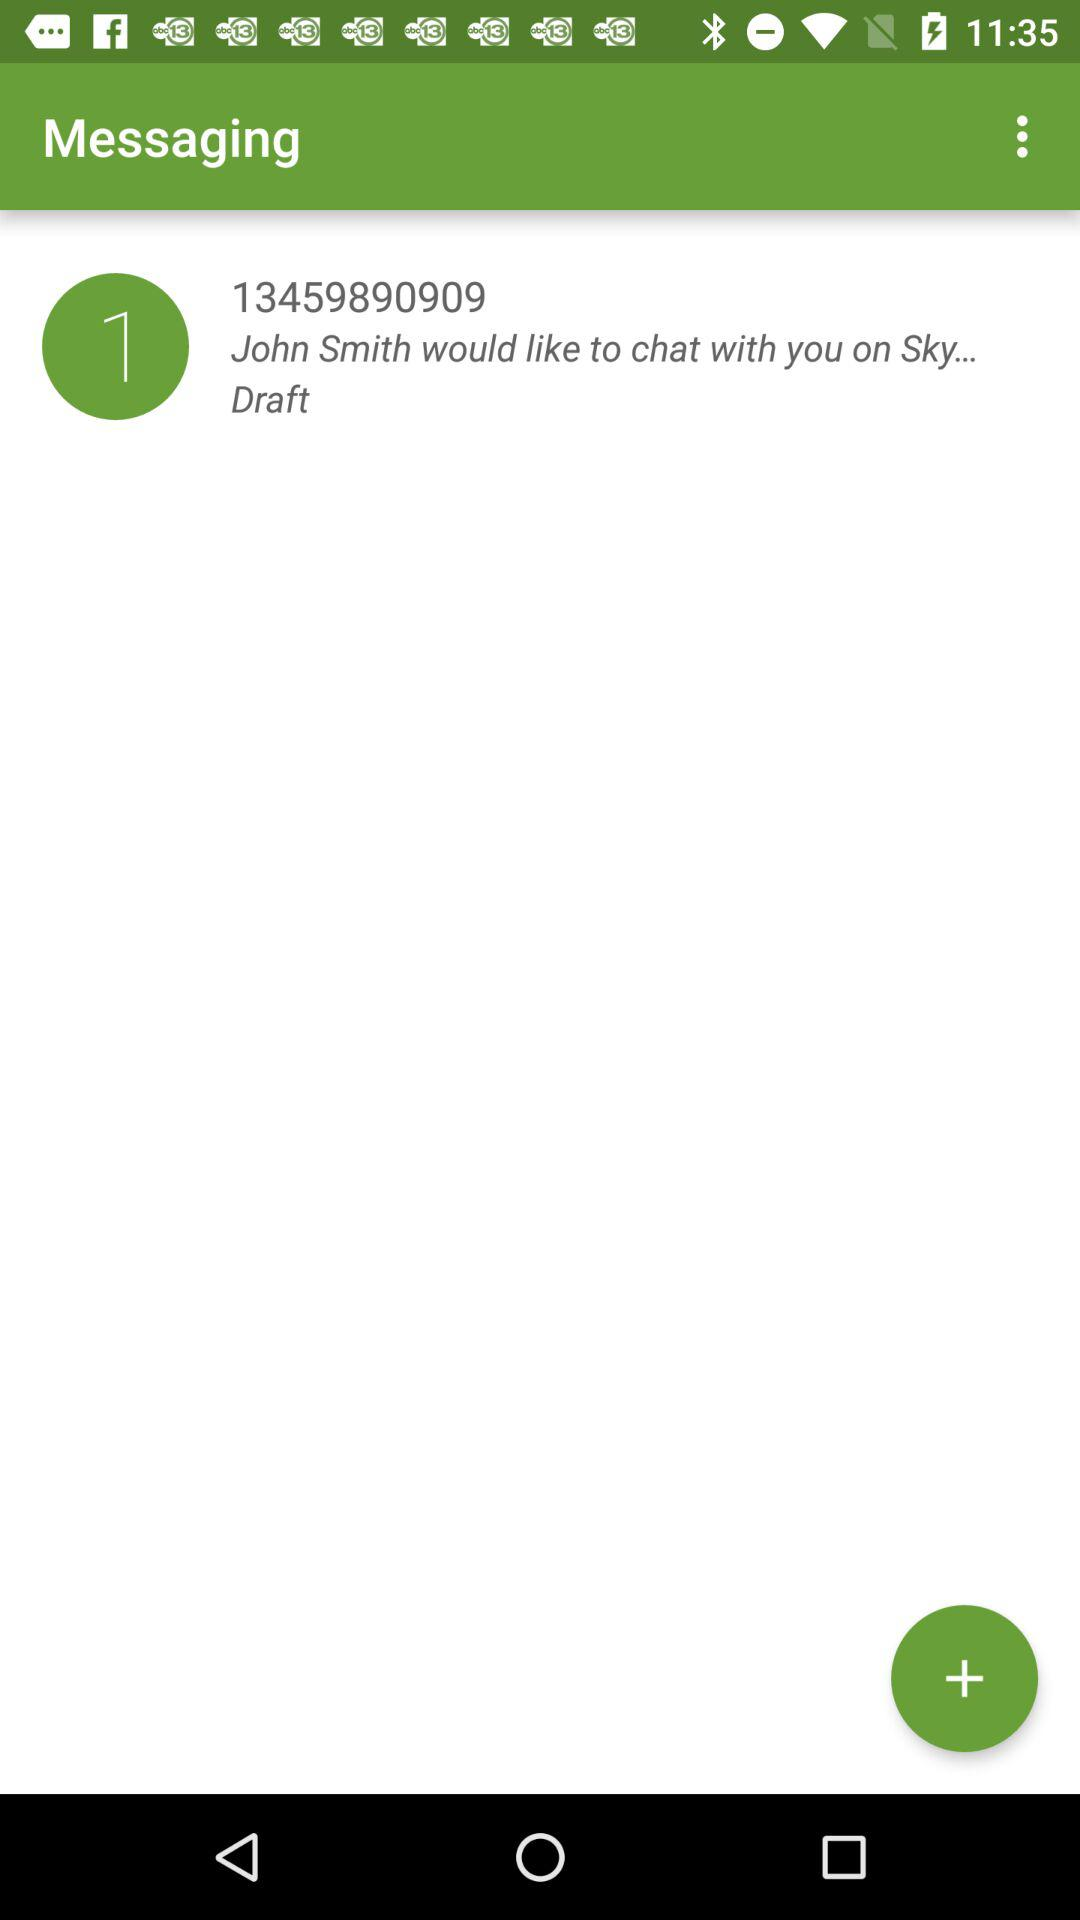What is John's phone number? John's phone number is 13459890909. 